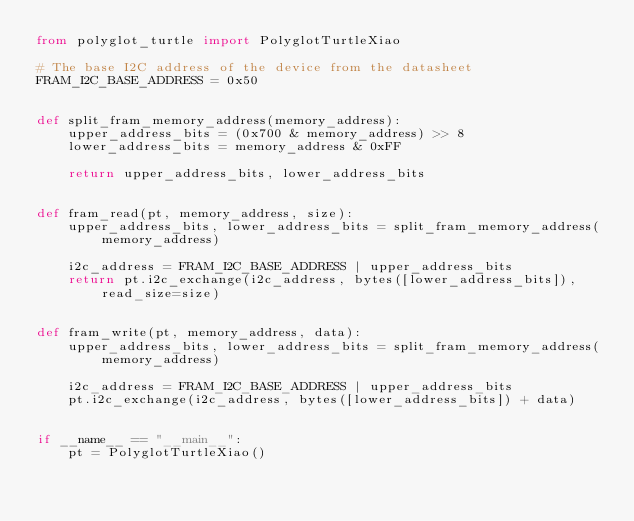<code> <loc_0><loc_0><loc_500><loc_500><_Python_>from polyglot_turtle import PolyglotTurtleXiao

# The base I2C address of the device from the datasheet
FRAM_I2C_BASE_ADDRESS = 0x50


def split_fram_memory_address(memory_address):
    upper_address_bits = (0x700 & memory_address) >> 8
    lower_address_bits = memory_address & 0xFF

    return upper_address_bits, lower_address_bits


def fram_read(pt, memory_address, size):
    upper_address_bits, lower_address_bits = split_fram_memory_address(memory_address)

    i2c_address = FRAM_I2C_BASE_ADDRESS | upper_address_bits
    return pt.i2c_exchange(i2c_address, bytes([lower_address_bits]), read_size=size)


def fram_write(pt, memory_address, data):
    upper_address_bits, lower_address_bits = split_fram_memory_address(memory_address)

    i2c_address = FRAM_I2C_BASE_ADDRESS | upper_address_bits
    pt.i2c_exchange(i2c_address, bytes([lower_address_bits]) + data)


if __name__ == "__main__":
    pt = PolyglotTurtleXiao()
</code> 